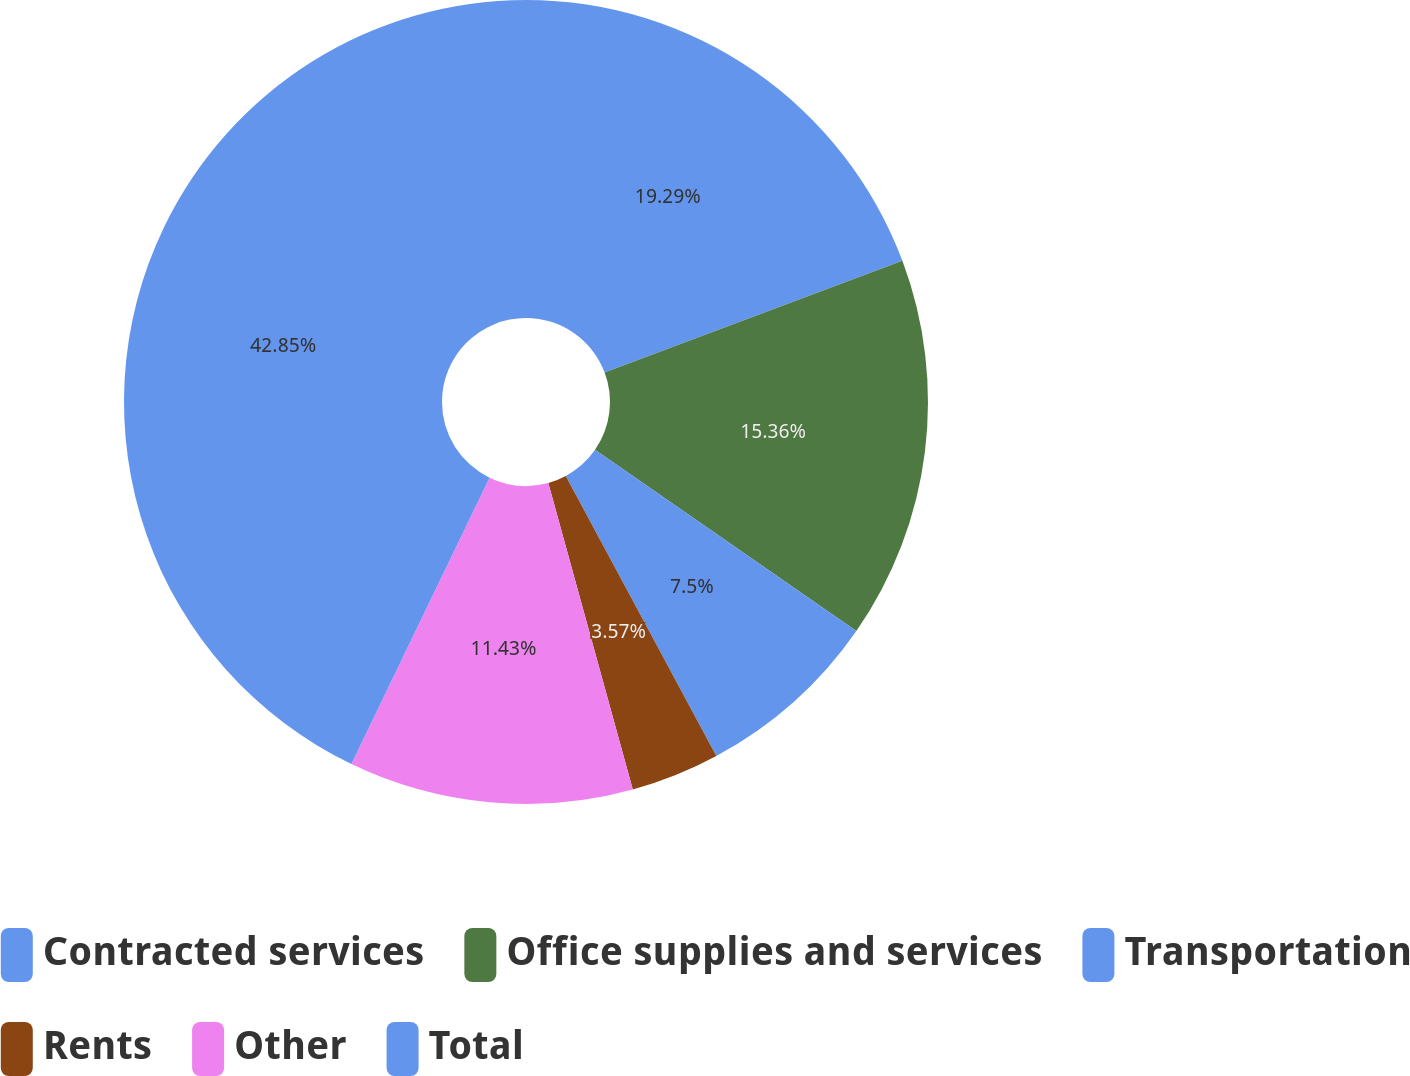Convert chart to OTSL. <chart><loc_0><loc_0><loc_500><loc_500><pie_chart><fcel>Contracted services<fcel>Office supplies and services<fcel>Transportation<fcel>Rents<fcel>Other<fcel>Total<nl><fcel>19.29%<fcel>15.36%<fcel>7.5%<fcel>3.57%<fcel>11.43%<fcel>42.85%<nl></chart> 